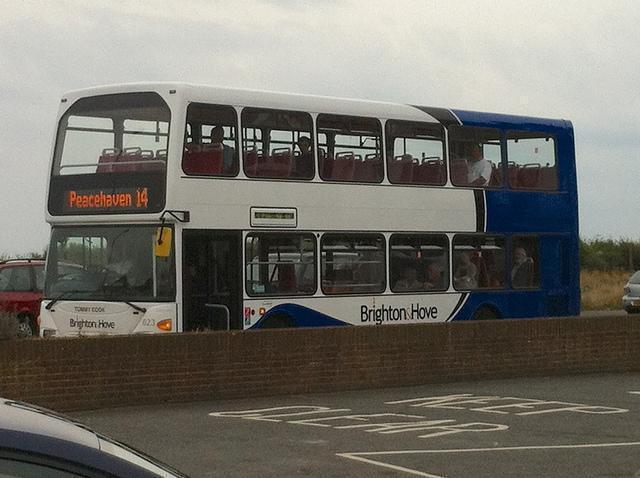In which country's streets does this bus travel?
Answer the question by selecting the correct answer among the 4 following choices.
Options: Briton, usa, spain, portugal. Briton. 